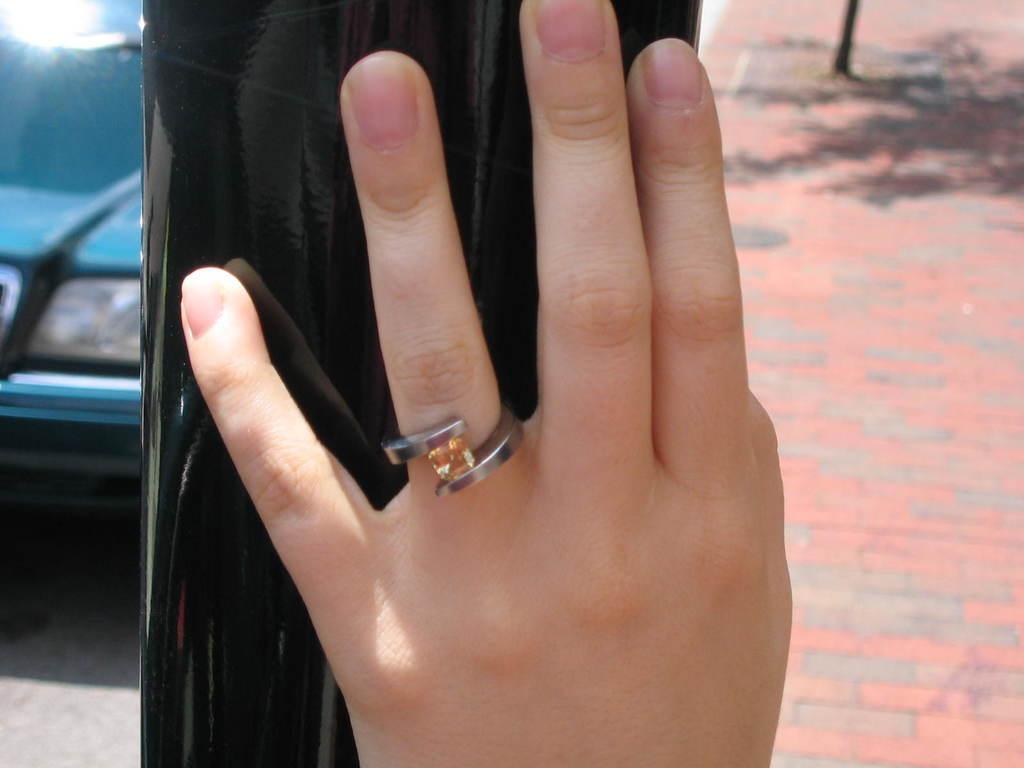Describe this image in one or two sentences. In the picture I can see a person's hand touching the pole and ring to the finger. In the background, I can see a car on the left side of the image and the sidewalk. 